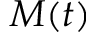Convert formula to latex. <formula><loc_0><loc_0><loc_500><loc_500>M ( t )</formula> 